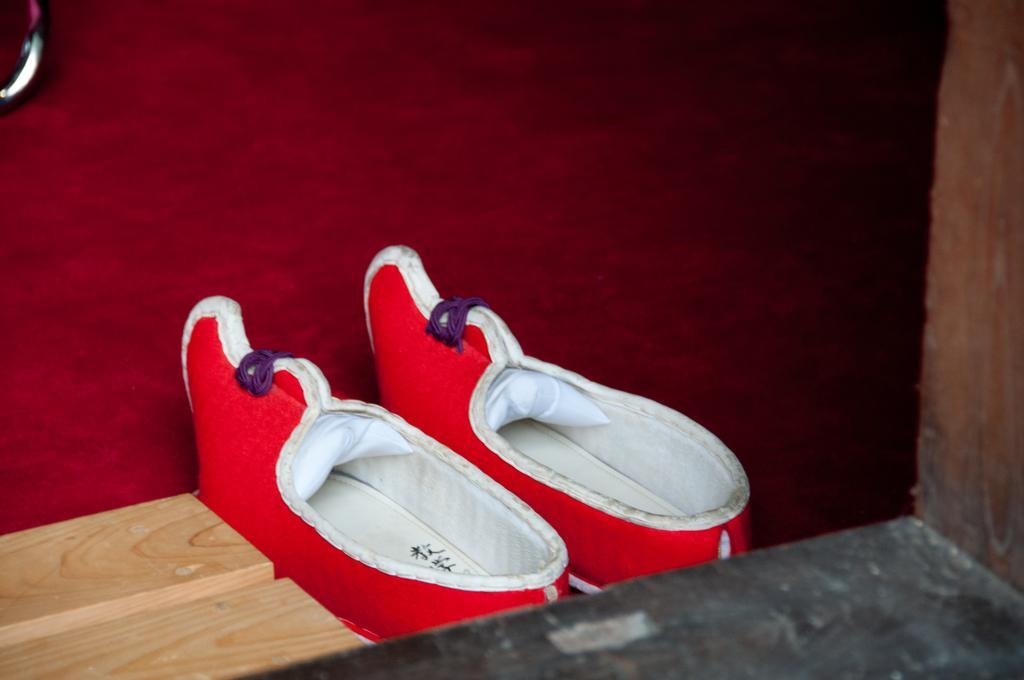Please provide a concise description of this image. In the image there is a pair of shoe on the floor and on the left side there is a wooden block. 